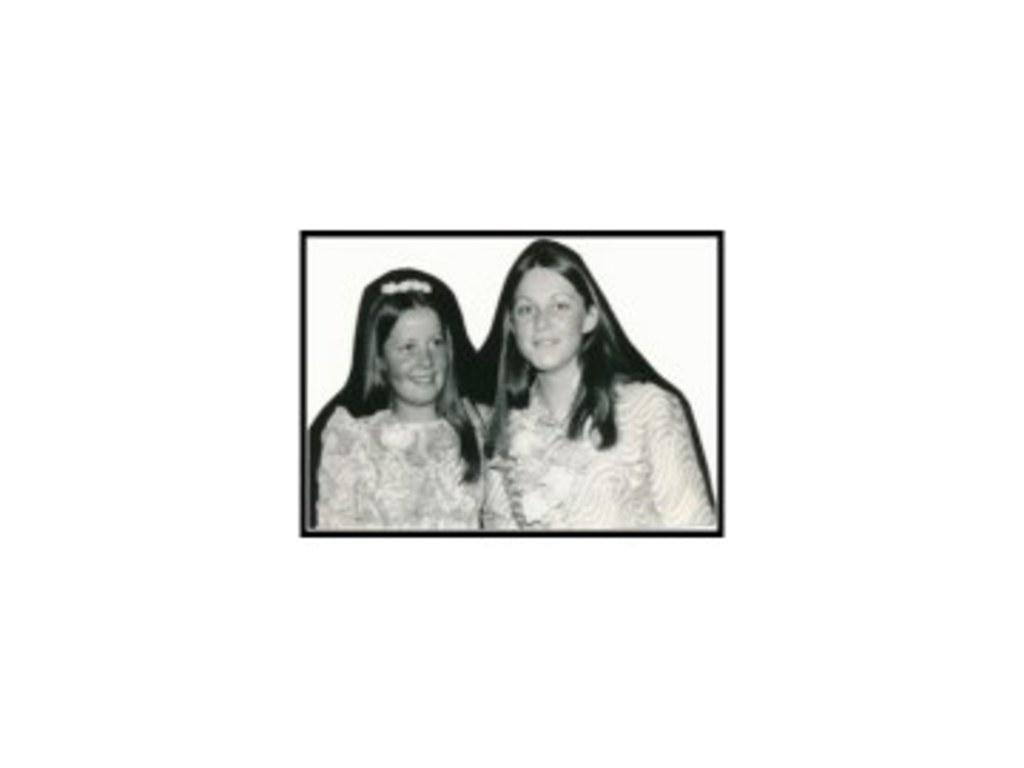What type of image is this? The image is a black and white photograph. What can be seen in the photograph? There are women in the photograph. What type of authority do the women have in the photograph? There is no information about the authority of the women in the photograph, as the facts provided only mention their presence. Is there a tent visible in the photograph? There is no mention of a tent in the provided facts, so it cannot be determined if one is present in the photograph. 